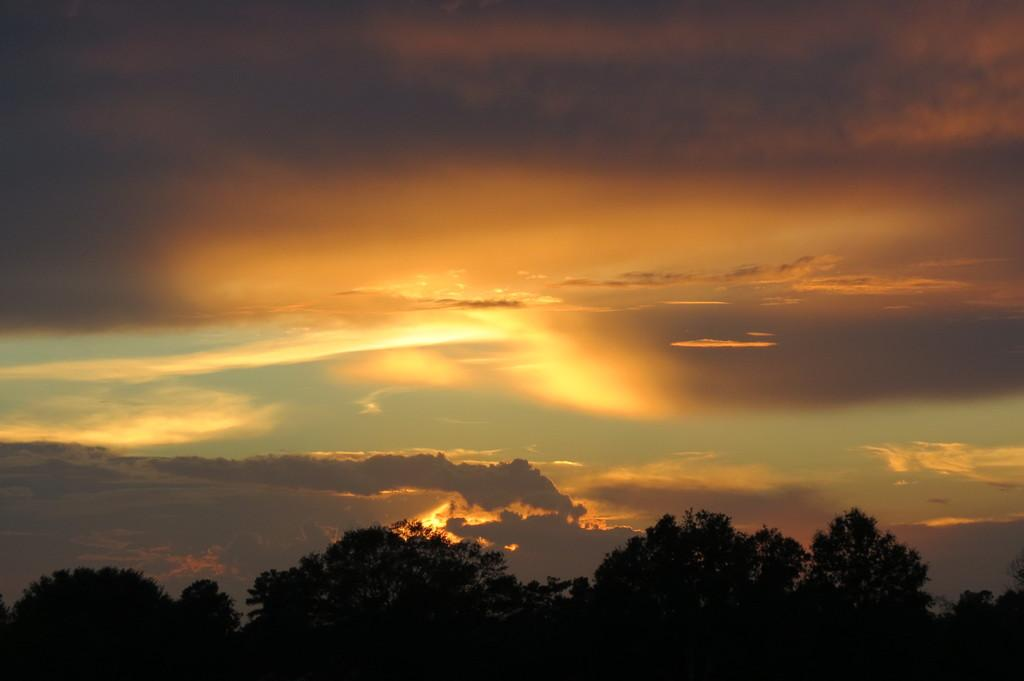What type of vegetation can be seen in the image? There are trees in the image. What can be seen in the sky in the image? There are clouds in the sky in the image. What word is written on the duck in the image? There is no duck present in the image, so it is not possible to answer that question. 